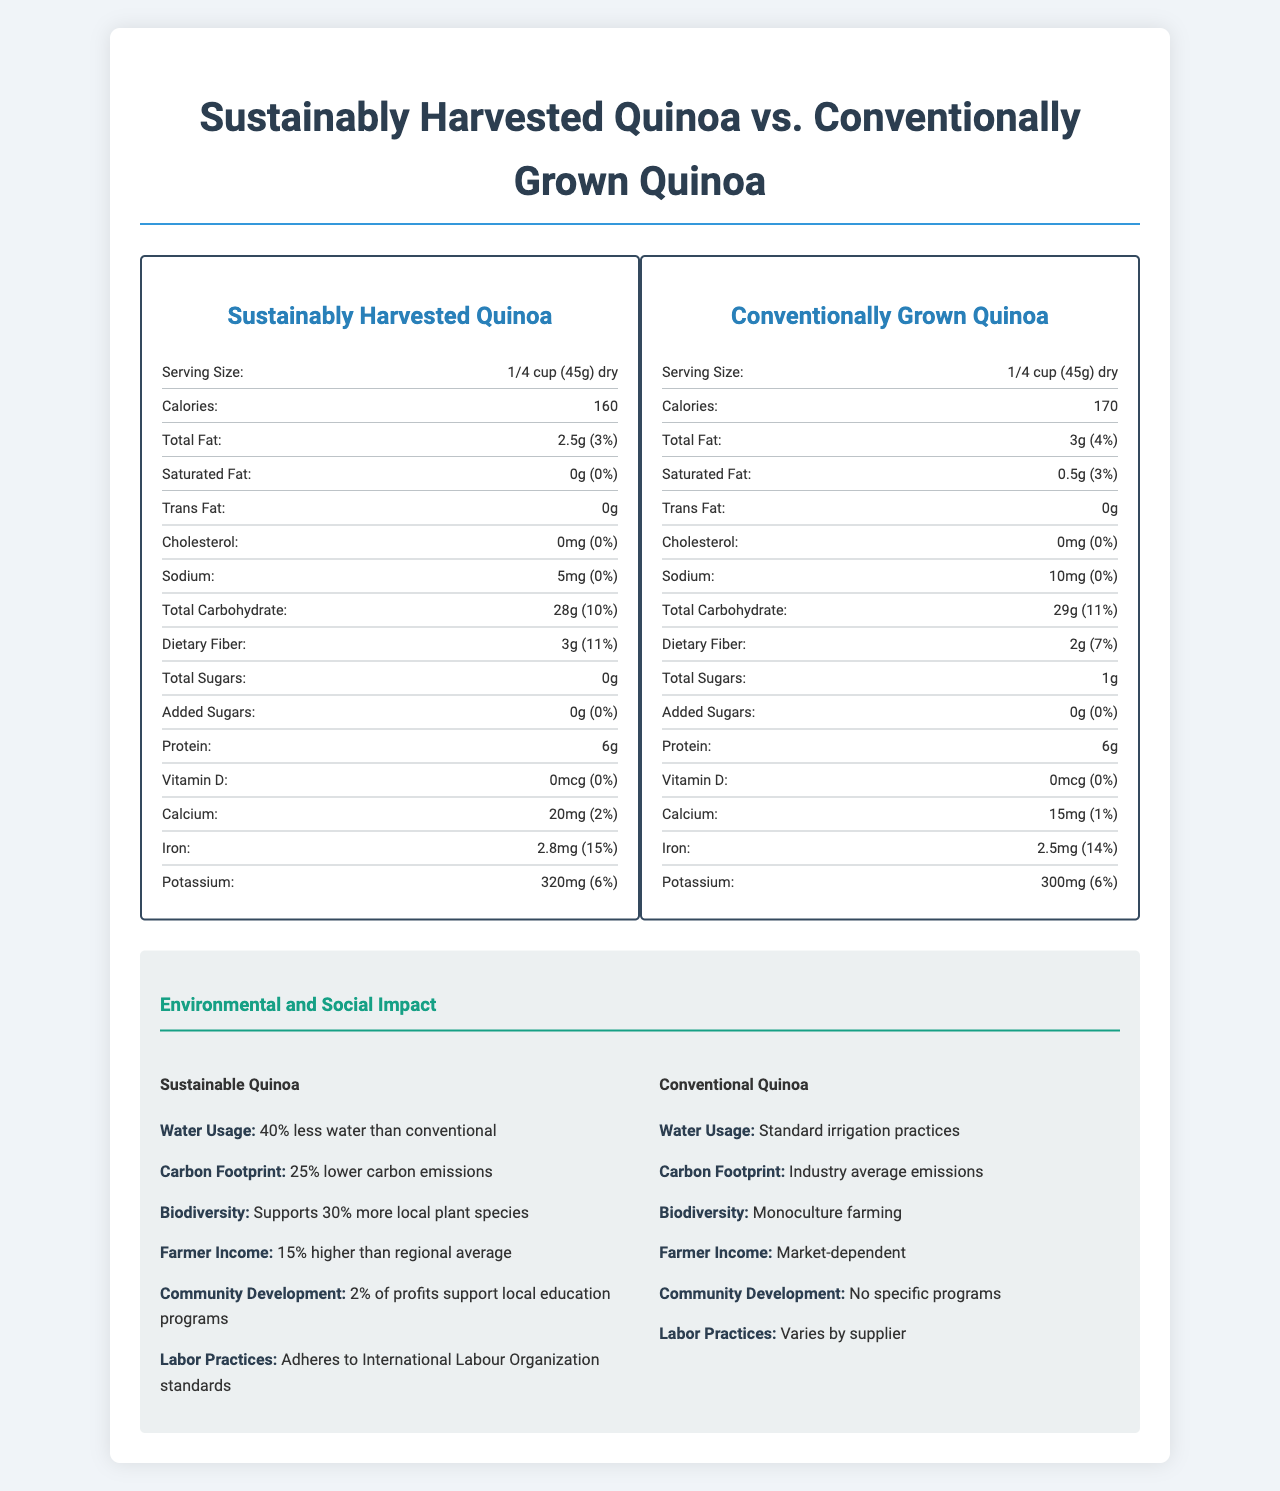what is the serving size for both types of quinoa? The serving size mentioned for both sustainably harvested and conventionally grown quinoa is 1/4 cup (45g) dry.
Answer: 1/4 cup (45g) dry how many calories are in a serving of sustainably harvested quinoa? The calories section indicates that sustainably harvested quinoa contains 160 calories per serving.
Answer: 160 how much total fat is in conventionally grown quinoa? The total fat content for conventionally grown quinoa is listed as 3g, which is 4% of the daily value.
Answer: 3g (4%) how does the dietary fiber content compare between the two types of quinoa? The nutrition label shows that sustainably harvested quinoa has higher dietary fiber content compared to conventionally grown quinoa.
Answer: Sustainably harvested quinoa has 3g (11%) of dietary fiber, while conventionally grown quinoa has 2g (7%) what certifications does sustainably harvested quinoa have? The additional info for sustainably harvested quinoa lists these certifications.
Answer: Certified Fair Trade, Non-GMO Project Verified, USDA Organic which type of quinoa has higher calcium content? The calcium content for sustainably harvested quinoa is 20mg (2%), which is higher than conventionally grown quinoa's 15mg (1%).
Answer: Sustainably harvested quinoa which type of quinoa has no trans fat? (Select the correct option)
A. Sustainably Harvested Quinoa
B. Conventionally Grown Quinoa 
C. Both The nutrition label for both types of quinoa lists the trans fat content as 0g.
Answer: C. Both how does the protein content of the two quinoas compare?
A. Sustainably harvested quinoa has more protein
B. Conventionally grown quinoa has more protein 
C. Both have the same protein content The protein content for both sustainably harvested and conventionally grown quinoa is 6g per serving.
Answer: C. Both have the same protein content does the sustainably harvested quinoa support community development? The social impact section states that 2% of the profits from sustainably harvested quinoa support local education programs.
Answer: Yes summarize the main differences between sustainably harvested and conventionally grown quinoa. The document compares sustainably harvested and conventionally grown quinoa across various nutritional, environmental, and social impact metrics, highlighting sustainability, community benefits, and nutritional differences.
Answer: Sustainably harvested quinoa uses 40% less water, has 25% lower carbon emissions, supports 30% more local plant species, provides 15% higher farmer income, and supports community development and international labor standards. Nutritionally, it has lower calories, total fat, and higher dietary fiber. Conventionally grown quinoa follows standard irrigation practices, has a usual carbon footprint, practices monoculture farming, and the farmers' income is market-dependent without specific community programs. who is the primary supplier for conventionally grown quinoa? The document does not provide specific details about the primary supplier for conventionally grown quinoa, only that it is sourced from multiple suppliers.
Answer: Not enough information 